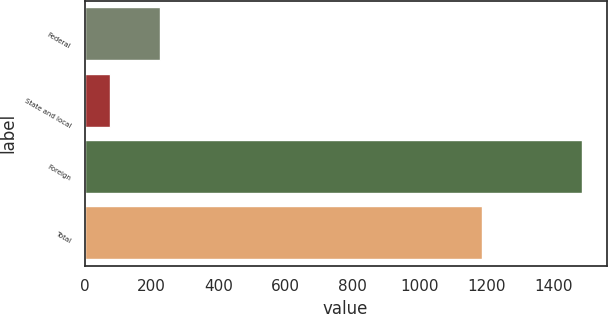<chart> <loc_0><loc_0><loc_500><loc_500><bar_chart><fcel>Federal<fcel>State and local<fcel>Foreign<fcel>Total<nl><fcel>224<fcel>75<fcel>1484<fcel>1185<nl></chart> 